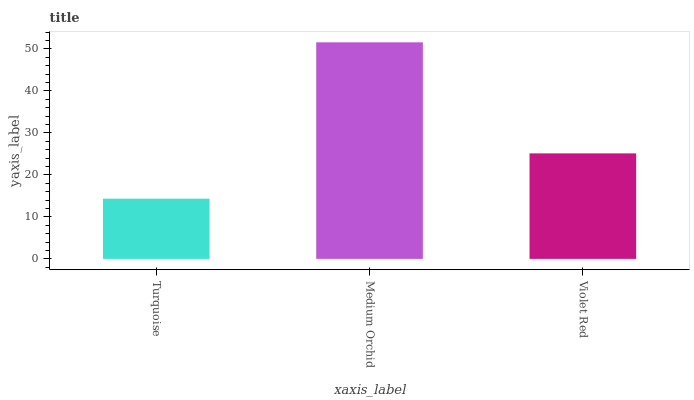Is Violet Red the minimum?
Answer yes or no. No. Is Violet Red the maximum?
Answer yes or no. No. Is Medium Orchid greater than Violet Red?
Answer yes or no. Yes. Is Violet Red less than Medium Orchid?
Answer yes or no. Yes. Is Violet Red greater than Medium Orchid?
Answer yes or no. No. Is Medium Orchid less than Violet Red?
Answer yes or no. No. Is Violet Red the high median?
Answer yes or no. Yes. Is Violet Red the low median?
Answer yes or no. Yes. Is Turquoise the high median?
Answer yes or no. No. Is Medium Orchid the low median?
Answer yes or no. No. 